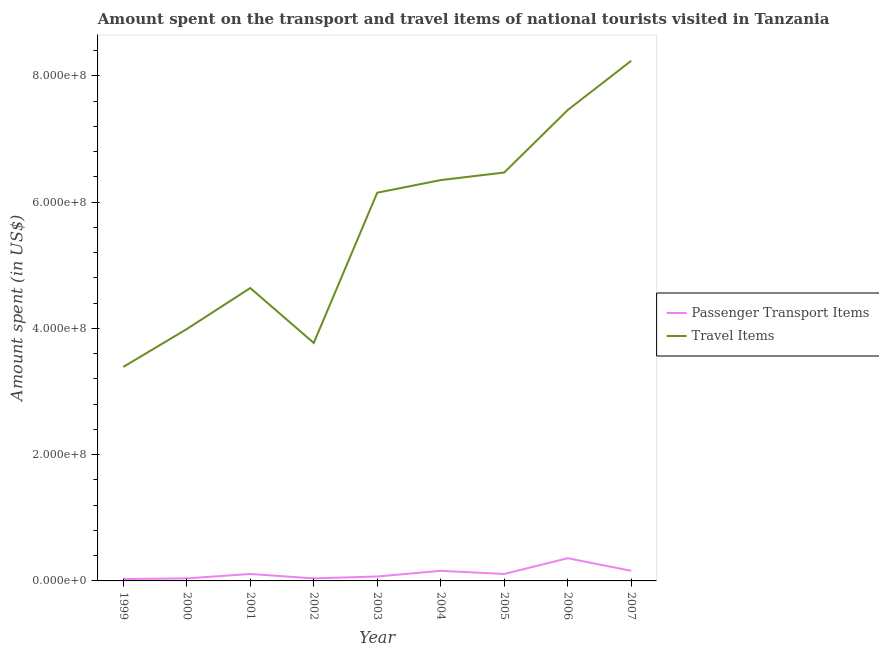Is the number of lines equal to the number of legend labels?
Your answer should be very brief. Yes. What is the amount spent on passenger transport items in 2001?
Offer a terse response. 1.10e+07. Across all years, what is the maximum amount spent on passenger transport items?
Your answer should be compact. 3.60e+07. Across all years, what is the minimum amount spent in travel items?
Your answer should be very brief. 3.39e+08. What is the total amount spent on passenger transport items in the graph?
Ensure brevity in your answer.  1.08e+08. What is the difference between the amount spent on passenger transport items in 2001 and that in 2002?
Offer a very short reply. 7.00e+06. What is the difference between the amount spent on passenger transport items in 2007 and the amount spent in travel items in 2001?
Keep it short and to the point. -4.48e+08. What is the average amount spent in travel items per year?
Your answer should be very brief. 5.61e+08. In the year 2005, what is the difference between the amount spent in travel items and amount spent on passenger transport items?
Your response must be concise. 6.36e+08. What is the ratio of the amount spent in travel items in 2003 to that in 2005?
Offer a very short reply. 0.95. Is the difference between the amount spent on passenger transport items in 2002 and 2007 greater than the difference between the amount spent in travel items in 2002 and 2007?
Offer a terse response. Yes. What is the difference between the highest and the second highest amount spent in travel items?
Your answer should be compact. 7.80e+07. What is the difference between the highest and the lowest amount spent in travel items?
Provide a short and direct response. 4.85e+08. In how many years, is the amount spent in travel items greater than the average amount spent in travel items taken over all years?
Make the answer very short. 5. Is the sum of the amount spent on passenger transport items in 2006 and 2007 greater than the maximum amount spent in travel items across all years?
Your answer should be very brief. No. Is the amount spent in travel items strictly greater than the amount spent on passenger transport items over the years?
Make the answer very short. Yes. Is the amount spent in travel items strictly less than the amount spent on passenger transport items over the years?
Offer a very short reply. No. How many lines are there?
Ensure brevity in your answer.  2. How many years are there in the graph?
Ensure brevity in your answer.  9. Are the values on the major ticks of Y-axis written in scientific E-notation?
Provide a succinct answer. Yes. Does the graph contain any zero values?
Provide a succinct answer. No. Does the graph contain grids?
Provide a short and direct response. No. Where does the legend appear in the graph?
Keep it short and to the point. Center right. What is the title of the graph?
Ensure brevity in your answer.  Amount spent on the transport and travel items of national tourists visited in Tanzania. What is the label or title of the X-axis?
Give a very brief answer. Year. What is the label or title of the Y-axis?
Your response must be concise. Amount spent (in US$). What is the Amount spent (in US$) in Travel Items in 1999?
Your response must be concise. 3.39e+08. What is the Amount spent (in US$) of Passenger Transport Items in 2000?
Provide a succinct answer. 4.00e+06. What is the Amount spent (in US$) in Travel Items in 2000?
Give a very brief answer. 3.99e+08. What is the Amount spent (in US$) in Passenger Transport Items in 2001?
Your answer should be compact. 1.10e+07. What is the Amount spent (in US$) in Travel Items in 2001?
Provide a short and direct response. 4.64e+08. What is the Amount spent (in US$) of Passenger Transport Items in 2002?
Provide a succinct answer. 4.00e+06. What is the Amount spent (in US$) in Travel Items in 2002?
Your answer should be compact. 3.77e+08. What is the Amount spent (in US$) of Passenger Transport Items in 2003?
Make the answer very short. 7.00e+06. What is the Amount spent (in US$) of Travel Items in 2003?
Give a very brief answer. 6.15e+08. What is the Amount spent (in US$) in Passenger Transport Items in 2004?
Offer a terse response. 1.60e+07. What is the Amount spent (in US$) in Travel Items in 2004?
Your answer should be very brief. 6.35e+08. What is the Amount spent (in US$) in Passenger Transport Items in 2005?
Provide a short and direct response. 1.10e+07. What is the Amount spent (in US$) of Travel Items in 2005?
Keep it short and to the point. 6.47e+08. What is the Amount spent (in US$) of Passenger Transport Items in 2006?
Keep it short and to the point. 3.60e+07. What is the Amount spent (in US$) in Travel Items in 2006?
Give a very brief answer. 7.46e+08. What is the Amount spent (in US$) of Passenger Transport Items in 2007?
Your answer should be compact. 1.60e+07. What is the Amount spent (in US$) in Travel Items in 2007?
Make the answer very short. 8.24e+08. Across all years, what is the maximum Amount spent (in US$) in Passenger Transport Items?
Your answer should be very brief. 3.60e+07. Across all years, what is the maximum Amount spent (in US$) of Travel Items?
Offer a very short reply. 8.24e+08. Across all years, what is the minimum Amount spent (in US$) in Travel Items?
Provide a short and direct response. 3.39e+08. What is the total Amount spent (in US$) of Passenger Transport Items in the graph?
Make the answer very short. 1.08e+08. What is the total Amount spent (in US$) in Travel Items in the graph?
Make the answer very short. 5.05e+09. What is the difference between the Amount spent (in US$) of Passenger Transport Items in 1999 and that in 2000?
Keep it short and to the point. -1.00e+06. What is the difference between the Amount spent (in US$) in Travel Items in 1999 and that in 2000?
Provide a short and direct response. -6.00e+07. What is the difference between the Amount spent (in US$) in Passenger Transport Items in 1999 and that in 2001?
Make the answer very short. -8.00e+06. What is the difference between the Amount spent (in US$) of Travel Items in 1999 and that in 2001?
Provide a short and direct response. -1.25e+08. What is the difference between the Amount spent (in US$) in Travel Items in 1999 and that in 2002?
Make the answer very short. -3.80e+07. What is the difference between the Amount spent (in US$) in Passenger Transport Items in 1999 and that in 2003?
Your response must be concise. -4.00e+06. What is the difference between the Amount spent (in US$) of Travel Items in 1999 and that in 2003?
Make the answer very short. -2.76e+08. What is the difference between the Amount spent (in US$) in Passenger Transport Items in 1999 and that in 2004?
Ensure brevity in your answer.  -1.30e+07. What is the difference between the Amount spent (in US$) in Travel Items in 1999 and that in 2004?
Give a very brief answer. -2.96e+08. What is the difference between the Amount spent (in US$) in Passenger Transport Items in 1999 and that in 2005?
Your answer should be very brief. -8.00e+06. What is the difference between the Amount spent (in US$) in Travel Items in 1999 and that in 2005?
Offer a very short reply. -3.08e+08. What is the difference between the Amount spent (in US$) in Passenger Transport Items in 1999 and that in 2006?
Provide a succinct answer. -3.30e+07. What is the difference between the Amount spent (in US$) of Travel Items in 1999 and that in 2006?
Give a very brief answer. -4.07e+08. What is the difference between the Amount spent (in US$) in Passenger Transport Items in 1999 and that in 2007?
Your response must be concise. -1.30e+07. What is the difference between the Amount spent (in US$) of Travel Items in 1999 and that in 2007?
Offer a very short reply. -4.85e+08. What is the difference between the Amount spent (in US$) of Passenger Transport Items in 2000 and that in 2001?
Your answer should be very brief. -7.00e+06. What is the difference between the Amount spent (in US$) in Travel Items in 2000 and that in 2001?
Ensure brevity in your answer.  -6.50e+07. What is the difference between the Amount spent (in US$) of Passenger Transport Items in 2000 and that in 2002?
Keep it short and to the point. 0. What is the difference between the Amount spent (in US$) in Travel Items in 2000 and that in 2002?
Ensure brevity in your answer.  2.20e+07. What is the difference between the Amount spent (in US$) in Travel Items in 2000 and that in 2003?
Provide a short and direct response. -2.16e+08. What is the difference between the Amount spent (in US$) of Passenger Transport Items in 2000 and that in 2004?
Offer a very short reply. -1.20e+07. What is the difference between the Amount spent (in US$) in Travel Items in 2000 and that in 2004?
Provide a short and direct response. -2.36e+08. What is the difference between the Amount spent (in US$) of Passenger Transport Items in 2000 and that in 2005?
Your answer should be compact. -7.00e+06. What is the difference between the Amount spent (in US$) of Travel Items in 2000 and that in 2005?
Give a very brief answer. -2.48e+08. What is the difference between the Amount spent (in US$) of Passenger Transport Items in 2000 and that in 2006?
Offer a very short reply. -3.20e+07. What is the difference between the Amount spent (in US$) of Travel Items in 2000 and that in 2006?
Give a very brief answer. -3.47e+08. What is the difference between the Amount spent (in US$) of Passenger Transport Items in 2000 and that in 2007?
Offer a terse response. -1.20e+07. What is the difference between the Amount spent (in US$) of Travel Items in 2000 and that in 2007?
Ensure brevity in your answer.  -4.25e+08. What is the difference between the Amount spent (in US$) in Passenger Transport Items in 2001 and that in 2002?
Ensure brevity in your answer.  7.00e+06. What is the difference between the Amount spent (in US$) in Travel Items in 2001 and that in 2002?
Offer a terse response. 8.70e+07. What is the difference between the Amount spent (in US$) of Travel Items in 2001 and that in 2003?
Give a very brief answer. -1.51e+08. What is the difference between the Amount spent (in US$) in Passenger Transport Items in 2001 and that in 2004?
Ensure brevity in your answer.  -5.00e+06. What is the difference between the Amount spent (in US$) of Travel Items in 2001 and that in 2004?
Offer a very short reply. -1.71e+08. What is the difference between the Amount spent (in US$) in Travel Items in 2001 and that in 2005?
Your answer should be very brief. -1.83e+08. What is the difference between the Amount spent (in US$) in Passenger Transport Items in 2001 and that in 2006?
Offer a very short reply. -2.50e+07. What is the difference between the Amount spent (in US$) of Travel Items in 2001 and that in 2006?
Your answer should be very brief. -2.82e+08. What is the difference between the Amount spent (in US$) of Passenger Transport Items in 2001 and that in 2007?
Your answer should be very brief. -5.00e+06. What is the difference between the Amount spent (in US$) of Travel Items in 2001 and that in 2007?
Offer a terse response. -3.60e+08. What is the difference between the Amount spent (in US$) in Passenger Transport Items in 2002 and that in 2003?
Provide a short and direct response. -3.00e+06. What is the difference between the Amount spent (in US$) of Travel Items in 2002 and that in 2003?
Give a very brief answer. -2.38e+08. What is the difference between the Amount spent (in US$) in Passenger Transport Items in 2002 and that in 2004?
Provide a short and direct response. -1.20e+07. What is the difference between the Amount spent (in US$) of Travel Items in 2002 and that in 2004?
Your answer should be very brief. -2.58e+08. What is the difference between the Amount spent (in US$) of Passenger Transport Items in 2002 and that in 2005?
Keep it short and to the point. -7.00e+06. What is the difference between the Amount spent (in US$) of Travel Items in 2002 and that in 2005?
Offer a terse response. -2.70e+08. What is the difference between the Amount spent (in US$) in Passenger Transport Items in 2002 and that in 2006?
Offer a very short reply. -3.20e+07. What is the difference between the Amount spent (in US$) in Travel Items in 2002 and that in 2006?
Provide a succinct answer. -3.69e+08. What is the difference between the Amount spent (in US$) of Passenger Transport Items in 2002 and that in 2007?
Provide a short and direct response. -1.20e+07. What is the difference between the Amount spent (in US$) in Travel Items in 2002 and that in 2007?
Make the answer very short. -4.47e+08. What is the difference between the Amount spent (in US$) in Passenger Transport Items in 2003 and that in 2004?
Your answer should be very brief. -9.00e+06. What is the difference between the Amount spent (in US$) in Travel Items in 2003 and that in 2004?
Your response must be concise. -2.00e+07. What is the difference between the Amount spent (in US$) of Travel Items in 2003 and that in 2005?
Offer a terse response. -3.20e+07. What is the difference between the Amount spent (in US$) in Passenger Transport Items in 2003 and that in 2006?
Your response must be concise. -2.90e+07. What is the difference between the Amount spent (in US$) of Travel Items in 2003 and that in 2006?
Make the answer very short. -1.31e+08. What is the difference between the Amount spent (in US$) of Passenger Transport Items in 2003 and that in 2007?
Provide a succinct answer. -9.00e+06. What is the difference between the Amount spent (in US$) in Travel Items in 2003 and that in 2007?
Provide a succinct answer. -2.09e+08. What is the difference between the Amount spent (in US$) of Travel Items in 2004 and that in 2005?
Your answer should be very brief. -1.20e+07. What is the difference between the Amount spent (in US$) in Passenger Transport Items in 2004 and that in 2006?
Your answer should be compact. -2.00e+07. What is the difference between the Amount spent (in US$) in Travel Items in 2004 and that in 2006?
Give a very brief answer. -1.11e+08. What is the difference between the Amount spent (in US$) of Passenger Transport Items in 2004 and that in 2007?
Offer a very short reply. 0. What is the difference between the Amount spent (in US$) in Travel Items in 2004 and that in 2007?
Make the answer very short. -1.89e+08. What is the difference between the Amount spent (in US$) in Passenger Transport Items in 2005 and that in 2006?
Offer a very short reply. -2.50e+07. What is the difference between the Amount spent (in US$) in Travel Items in 2005 and that in 2006?
Ensure brevity in your answer.  -9.90e+07. What is the difference between the Amount spent (in US$) in Passenger Transport Items in 2005 and that in 2007?
Offer a very short reply. -5.00e+06. What is the difference between the Amount spent (in US$) in Travel Items in 2005 and that in 2007?
Keep it short and to the point. -1.77e+08. What is the difference between the Amount spent (in US$) of Passenger Transport Items in 2006 and that in 2007?
Offer a terse response. 2.00e+07. What is the difference between the Amount spent (in US$) of Travel Items in 2006 and that in 2007?
Provide a succinct answer. -7.80e+07. What is the difference between the Amount spent (in US$) of Passenger Transport Items in 1999 and the Amount spent (in US$) of Travel Items in 2000?
Keep it short and to the point. -3.96e+08. What is the difference between the Amount spent (in US$) in Passenger Transport Items in 1999 and the Amount spent (in US$) in Travel Items in 2001?
Provide a succinct answer. -4.61e+08. What is the difference between the Amount spent (in US$) of Passenger Transport Items in 1999 and the Amount spent (in US$) of Travel Items in 2002?
Your response must be concise. -3.74e+08. What is the difference between the Amount spent (in US$) in Passenger Transport Items in 1999 and the Amount spent (in US$) in Travel Items in 2003?
Offer a terse response. -6.12e+08. What is the difference between the Amount spent (in US$) of Passenger Transport Items in 1999 and the Amount spent (in US$) of Travel Items in 2004?
Make the answer very short. -6.32e+08. What is the difference between the Amount spent (in US$) in Passenger Transport Items in 1999 and the Amount spent (in US$) in Travel Items in 2005?
Provide a succinct answer. -6.44e+08. What is the difference between the Amount spent (in US$) of Passenger Transport Items in 1999 and the Amount spent (in US$) of Travel Items in 2006?
Your answer should be very brief. -7.43e+08. What is the difference between the Amount spent (in US$) in Passenger Transport Items in 1999 and the Amount spent (in US$) in Travel Items in 2007?
Give a very brief answer. -8.21e+08. What is the difference between the Amount spent (in US$) of Passenger Transport Items in 2000 and the Amount spent (in US$) of Travel Items in 2001?
Make the answer very short. -4.60e+08. What is the difference between the Amount spent (in US$) in Passenger Transport Items in 2000 and the Amount spent (in US$) in Travel Items in 2002?
Your answer should be compact. -3.73e+08. What is the difference between the Amount spent (in US$) in Passenger Transport Items in 2000 and the Amount spent (in US$) in Travel Items in 2003?
Offer a very short reply. -6.11e+08. What is the difference between the Amount spent (in US$) in Passenger Transport Items in 2000 and the Amount spent (in US$) in Travel Items in 2004?
Keep it short and to the point. -6.31e+08. What is the difference between the Amount spent (in US$) in Passenger Transport Items in 2000 and the Amount spent (in US$) in Travel Items in 2005?
Ensure brevity in your answer.  -6.43e+08. What is the difference between the Amount spent (in US$) in Passenger Transport Items in 2000 and the Amount spent (in US$) in Travel Items in 2006?
Your answer should be very brief. -7.42e+08. What is the difference between the Amount spent (in US$) in Passenger Transport Items in 2000 and the Amount spent (in US$) in Travel Items in 2007?
Keep it short and to the point. -8.20e+08. What is the difference between the Amount spent (in US$) in Passenger Transport Items in 2001 and the Amount spent (in US$) in Travel Items in 2002?
Offer a very short reply. -3.66e+08. What is the difference between the Amount spent (in US$) of Passenger Transport Items in 2001 and the Amount spent (in US$) of Travel Items in 2003?
Keep it short and to the point. -6.04e+08. What is the difference between the Amount spent (in US$) in Passenger Transport Items in 2001 and the Amount spent (in US$) in Travel Items in 2004?
Give a very brief answer. -6.24e+08. What is the difference between the Amount spent (in US$) in Passenger Transport Items in 2001 and the Amount spent (in US$) in Travel Items in 2005?
Offer a terse response. -6.36e+08. What is the difference between the Amount spent (in US$) of Passenger Transport Items in 2001 and the Amount spent (in US$) of Travel Items in 2006?
Your response must be concise. -7.35e+08. What is the difference between the Amount spent (in US$) of Passenger Transport Items in 2001 and the Amount spent (in US$) of Travel Items in 2007?
Make the answer very short. -8.13e+08. What is the difference between the Amount spent (in US$) in Passenger Transport Items in 2002 and the Amount spent (in US$) in Travel Items in 2003?
Keep it short and to the point. -6.11e+08. What is the difference between the Amount spent (in US$) of Passenger Transport Items in 2002 and the Amount spent (in US$) of Travel Items in 2004?
Ensure brevity in your answer.  -6.31e+08. What is the difference between the Amount spent (in US$) of Passenger Transport Items in 2002 and the Amount spent (in US$) of Travel Items in 2005?
Your response must be concise. -6.43e+08. What is the difference between the Amount spent (in US$) of Passenger Transport Items in 2002 and the Amount spent (in US$) of Travel Items in 2006?
Ensure brevity in your answer.  -7.42e+08. What is the difference between the Amount spent (in US$) of Passenger Transport Items in 2002 and the Amount spent (in US$) of Travel Items in 2007?
Keep it short and to the point. -8.20e+08. What is the difference between the Amount spent (in US$) in Passenger Transport Items in 2003 and the Amount spent (in US$) in Travel Items in 2004?
Your response must be concise. -6.28e+08. What is the difference between the Amount spent (in US$) in Passenger Transport Items in 2003 and the Amount spent (in US$) in Travel Items in 2005?
Offer a terse response. -6.40e+08. What is the difference between the Amount spent (in US$) in Passenger Transport Items in 2003 and the Amount spent (in US$) in Travel Items in 2006?
Ensure brevity in your answer.  -7.39e+08. What is the difference between the Amount spent (in US$) of Passenger Transport Items in 2003 and the Amount spent (in US$) of Travel Items in 2007?
Provide a succinct answer. -8.17e+08. What is the difference between the Amount spent (in US$) in Passenger Transport Items in 2004 and the Amount spent (in US$) in Travel Items in 2005?
Your response must be concise. -6.31e+08. What is the difference between the Amount spent (in US$) in Passenger Transport Items in 2004 and the Amount spent (in US$) in Travel Items in 2006?
Make the answer very short. -7.30e+08. What is the difference between the Amount spent (in US$) in Passenger Transport Items in 2004 and the Amount spent (in US$) in Travel Items in 2007?
Provide a short and direct response. -8.08e+08. What is the difference between the Amount spent (in US$) of Passenger Transport Items in 2005 and the Amount spent (in US$) of Travel Items in 2006?
Offer a very short reply. -7.35e+08. What is the difference between the Amount spent (in US$) of Passenger Transport Items in 2005 and the Amount spent (in US$) of Travel Items in 2007?
Make the answer very short. -8.13e+08. What is the difference between the Amount spent (in US$) of Passenger Transport Items in 2006 and the Amount spent (in US$) of Travel Items in 2007?
Give a very brief answer. -7.88e+08. What is the average Amount spent (in US$) in Passenger Transport Items per year?
Offer a terse response. 1.20e+07. What is the average Amount spent (in US$) in Travel Items per year?
Your response must be concise. 5.61e+08. In the year 1999, what is the difference between the Amount spent (in US$) in Passenger Transport Items and Amount spent (in US$) in Travel Items?
Your response must be concise. -3.36e+08. In the year 2000, what is the difference between the Amount spent (in US$) of Passenger Transport Items and Amount spent (in US$) of Travel Items?
Ensure brevity in your answer.  -3.95e+08. In the year 2001, what is the difference between the Amount spent (in US$) of Passenger Transport Items and Amount spent (in US$) of Travel Items?
Provide a short and direct response. -4.53e+08. In the year 2002, what is the difference between the Amount spent (in US$) of Passenger Transport Items and Amount spent (in US$) of Travel Items?
Offer a terse response. -3.73e+08. In the year 2003, what is the difference between the Amount spent (in US$) in Passenger Transport Items and Amount spent (in US$) in Travel Items?
Your answer should be compact. -6.08e+08. In the year 2004, what is the difference between the Amount spent (in US$) in Passenger Transport Items and Amount spent (in US$) in Travel Items?
Offer a very short reply. -6.19e+08. In the year 2005, what is the difference between the Amount spent (in US$) of Passenger Transport Items and Amount spent (in US$) of Travel Items?
Your response must be concise. -6.36e+08. In the year 2006, what is the difference between the Amount spent (in US$) in Passenger Transport Items and Amount spent (in US$) in Travel Items?
Give a very brief answer. -7.10e+08. In the year 2007, what is the difference between the Amount spent (in US$) in Passenger Transport Items and Amount spent (in US$) in Travel Items?
Your answer should be very brief. -8.08e+08. What is the ratio of the Amount spent (in US$) in Passenger Transport Items in 1999 to that in 2000?
Your answer should be very brief. 0.75. What is the ratio of the Amount spent (in US$) of Travel Items in 1999 to that in 2000?
Your answer should be very brief. 0.85. What is the ratio of the Amount spent (in US$) in Passenger Transport Items in 1999 to that in 2001?
Ensure brevity in your answer.  0.27. What is the ratio of the Amount spent (in US$) in Travel Items in 1999 to that in 2001?
Make the answer very short. 0.73. What is the ratio of the Amount spent (in US$) in Passenger Transport Items in 1999 to that in 2002?
Make the answer very short. 0.75. What is the ratio of the Amount spent (in US$) of Travel Items in 1999 to that in 2002?
Give a very brief answer. 0.9. What is the ratio of the Amount spent (in US$) of Passenger Transport Items in 1999 to that in 2003?
Your answer should be compact. 0.43. What is the ratio of the Amount spent (in US$) in Travel Items in 1999 to that in 2003?
Your answer should be compact. 0.55. What is the ratio of the Amount spent (in US$) in Passenger Transport Items in 1999 to that in 2004?
Ensure brevity in your answer.  0.19. What is the ratio of the Amount spent (in US$) in Travel Items in 1999 to that in 2004?
Offer a very short reply. 0.53. What is the ratio of the Amount spent (in US$) of Passenger Transport Items in 1999 to that in 2005?
Provide a succinct answer. 0.27. What is the ratio of the Amount spent (in US$) in Travel Items in 1999 to that in 2005?
Ensure brevity in your answer.  0.52. What is the ratio of the Amount spent (in US$) in Passenger Transport Items in 1999 to that in 2006?
Keep it short and to the point. 0.08. What is the ratio of the Amount spent (in US$) of Travel Items in 1999 to that in 2006?
Provide a succinct answer. 0.45. What is the ratio of the Amount spent (in US$) of Passenger Transport Items in 1999 to that in 2007?
Your response must be concise. 0.19. What is the ratio of the Amount spent (in US$) in Travel Items in 1999 to that in 2007?
Give a very brief answer. 0.41. What is the ratio of the Amount spent (in US$) of Passenger Transport Items in 2000 to that in 2001?
Your response must be concise. 0.36. What is the ratio of the Amount spent (in US$) in Travel Items in 2000 to that in 2001?
Provide a short and direct response. 0.86. What is the ratio of the Amount spent (in US$) of Passenger Transport Items in 2000 to that in 2002?
Keep it short and to the point. 1. What is the ratio of the Amount spent (in US$) of Travel Items in 2000 to that in 2002?
Make the answer very short. 1.06. What is the ratio of the Amount spent (in US$) in Travel Items in 2000 to that in 2003?
Make the answer very short. 0.65. What is the ratio of the Amount spent (in US$) of Passenger Transport Items in 2000 to that in 2004?
Provide a succinct answer. 0.25. What is the ratio of the Amount spent (in US$) in Travel Items in 2000 to that in 2004?
Provide a succinct answer. 0.63. What is the ratio of the Amount spent (in US$) of Passenger Transport Items in 2000 to that in 2005?
Offer a terse response. 0.36. What is the ratio of the Amount spent (in US$) in Travel Items in 2000 to that in 2005?
Your answer should be compact. 0.62. What is the ratio of the Amount spent (in US$) in Passenger Transport Items in 2000 to that in 2006?
Offer a terse response. 0.11. What is the ratio of the Amount spent (in US$) of Travel Items in 2000 to that in 2006?
Your response must be concise. 0.53. What is the ratio of the Amount spent (in US$) in Passenger Transport Items in 2000 to that in 2007?
Your answer should be very brief. 0.25. What is the ratio of the Amount spent (in US$) in Travel Items in 2000 to that in 2007?
Offer a very short reply. 0.48. What is the ratio of the Amount spent (in US$) of Passenger Transport Items in 2001 to that in 2002?
Offer a very short reply. 2.75. What is the ratio of the Amount spent (in US$) in Travel Items in 2001 to that in 2002?
Ensure brevity in your answer.  1.23. What is the ratio of the Amount spent (in US$) in Passenger Transport Items in 2001 to that in 2003?
Keep it short and to the point. 1.57. What is the ratio of the Amount spent (in US$) in Travel Items in 2001 to that in 2003?
Keep it short and to the point. 0.75. What is the ratio of the Amount spent (in US$) in Passenger Transport Items in 2001 to that in 2004?
Provide a succinct answer. 0.69. What is the ratio of the Amount spent (in US$) in Travel Items in 2001 to that in 2004?
Ensure brevity in your answer.  0.73. What is the ratio of the Amount spent (in US$) of Travel Items in 2001 to that in 2005?
Keep it short and to the point. 0.72. What is the ratio of the Amount spent (in US$) of Passenger Transport Items in 2001 to that in 2006?
Ensure brevity in your answer.  0.31. What is the ratio of the Amount spent (in US$) of Travel Items in 2001 to that in 2006?
Your answer should be very brief. 0.62. What is the ratio of the Amount spent (in US$) in Passenger Transport Items in 2001 to that in 2007?
Give a very brief answer. 0.69. What is the ratio of the Amount spent (in US$) of Travel Items in 2001 to that in 2007?
Keep it short and to the point. 0.56. What is the ratio of the Amount spent (in US$) of Travel Items in 2002 to that in 2003?
Give a very brief answer. 0.61. What is the ratio of the Amount spent (in US$) of Passenger Transport Items in 2002 to that in 2004?
Make the answer very short. 0.25. What is the ratio of the Amount spent (in US$) in Travel Items in 2002 to that in 2004?
Offer a very short reply. 0.59. What is the ratio of the Amount spent (in US$) of Passenger Transport Items in 2002 to that in 2005?
Provide a succinct answer. 0.36. What is the ratio of the Amount spent (in US$) of Travel Items in 2002 to that in 2005?
Your answer should be compact. 0.58. What is the ratio of the Amount spent (in US$) of Travel Items in 2002 to that in 2006?
Give a very brief answer. 0.51. What is the ratio of the Amount spent (in US$) of Travel Items in 2002 to that in 2007?
Make the answer very short. 0.46. What is the ratio of the Amount spent (in US$) in Passenger Transport Items in 2003 to that in 2004?
Your response must be concise. 0.44. What is the ratio of the Amount spent (in US$) of Travel Items in 2003 to that in 2004?
Provide a short and direct response. 0.97. What is the ratio of the Amount spent (in US$) in Passenger Transport Items in 2003 to that in 2005?
Offer a terse response. 0.64. What is the ratio of the Amount spent (in US$) in Travel Items in 2003 to that in 2005?
Make the answer very short. 0.95. What is the ratio of the Amount spent (in US$) of Passenger Transport Items in 2003 to that in 2006?
Ensure brevity in your answer.  0.19. What is the ratio of the Amount spent (in US$) in Travel Items in 2003 to that in 2006?
Offer a very short reply. 0.82. What is the ratio of the Amount spent (in US$) of Passenger Transport Items in 2003 to that in 2007?
Make the answer very short. 0.44. What is the ratio of the Amount spent (in US$) of Travel Items in 2003 to that in 2007?
Provide a short and direct response. 0.75. What is the ratio of the Amount spent (in US$) of Passenger Transport Items in 2004 to that in 2005?
Provide a succinct answer. 1.45. What is the ratio of the Amount spent (in US$) of Travel Items in 2004 to that in 2005?
Your response must be concise. 0.98. What is the ratio of the Amount spent (in US$) in Passenger Transport Items in 2004 to that in 2006?
Provide a short and direct response. 0.44. What is the ratio of the Amount spent (in US$) of Travel Items in 2004 to that in 2006?
Your response must be concise. 0.85. What is the ratio of the Amount spent (in US$) of Passenger Transport Items in 2004 to that in 2007?
Offer a terse response. 1. What is the ratio of the Amount spent (in US$) of Travel Items in 2004 to that in 2007?
Give a very brief answer. 0.77. What is the ratio of the Amount spent (in US$) of Passenger Transport Items in 2005 to that in 2006?
Your answer should be very brief. 0.31. What is the ratio of the Amount spent (in US$) in Travel Items in 2005 to that in 2006?
Offer a very short reply. 0.87. What is the ratio of the Amount spent (in US$) in Passenger Transport Items in 2005 to that in 2007?
Ensure brevity in your answer.  0.69. What is the ratio of the Amount spent (in US$) in Travel Items in 2005 to that in 2007?
Offer a terse response. 0.79. What is the ratio of the Amount spent (in US$) in Passenger Transport Items in 2006 to that in 2007?
Offer a very short reply. 2.25. What is the ratio of the Amount spent (in US$) in Travel Items in 2006 to that in 2007?
Make the answer very short. 0.91. What is the difference between the highest and the second highest Amount spent (in US$) of Passenger Transport Items?
Provide a succinct answer. 2.00e+07. What is the difference between the highest and the second highest Amount spent (in US$) in Travel Items?
Offer a terse response. 7.80e+07. What is the difference between the highest and the lowest Amount spent (in US$) of Passenger Transport Items?
Keep it short and to the point. 3.30e+07. What is the difference between the highest and the lowest Amount spent (in US$) in Travel Items?
Your answer should be very brief. 4.85e+08. 